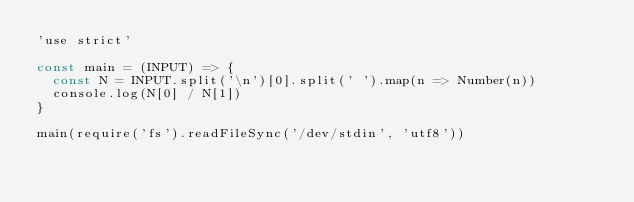<code> <loc_0><loc_0><loc_500><loc_500><_JavaScript_>'use strict'

const main = (INPUT) => {
  const N = INPUT.split('\n')[0].split(' ').map(n => Number(n))
  console.log(N[0] / N[1])
}

main(require('fs').readFileSync('/dev/stdin', 'utf8'))
</code> 